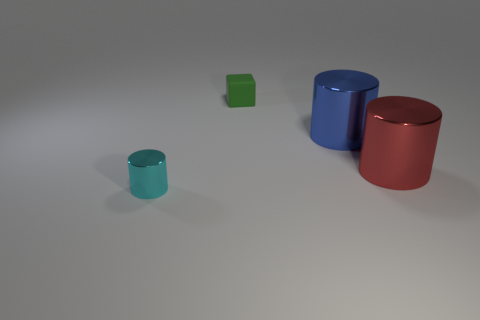What colors are the cylinders in the image? The cylinders in the image come in three colors: green, blue, and red. 